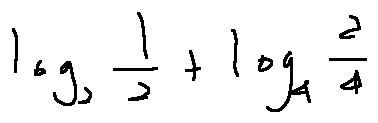<formula> <loc_0><loc_0><loc_500><loc_500>\log _ { 2 } \frac { 1 } { 2 } + \log _ { 4 } \frac { 2 } { 4 }</formula> 